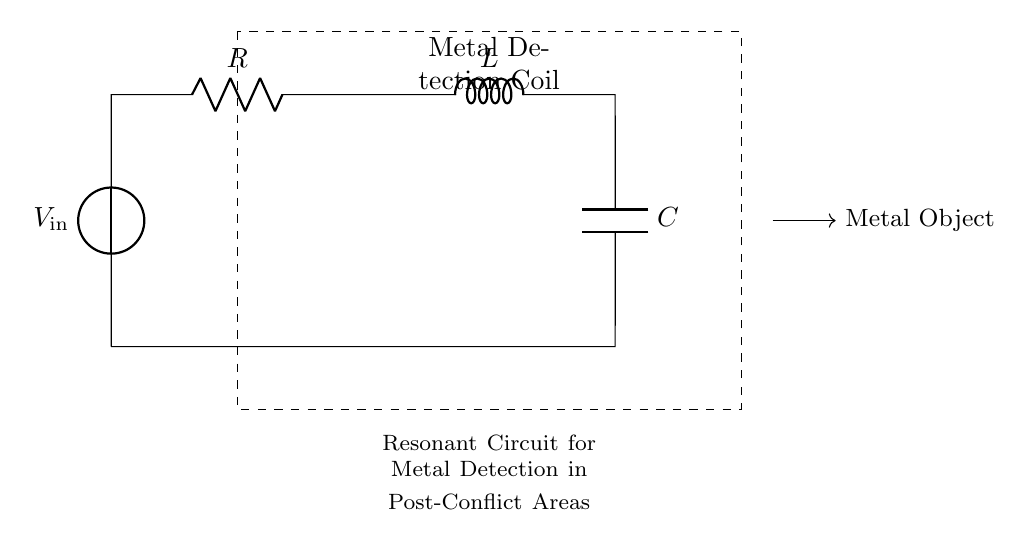What components are in the circuit? The circuit contains a voltage source, a resistor, an inductor, and a capacitor. These components are arranged in a loop, demonstrating a basic resonant circuit.
Answer: Voltage source, resistor, inductor, capacitor What does the dashed rectangle represent? The dashed rectangle encloses the metal detection coil, indicating the specific area of the circuit where metal detection occurs. It labels this section for clarity.
Answer: Metal Detection Coil How does the circuit detect metal? The circuit detects metal by utilizing the resonant frequency, which changes in the presence of a metal object due to changes in the inductive and capacitive components. When metal is present, it affects the circuit's inductance, altering the resonant frequency.
Answer: Changes in resonant frequency What is the primary function of the inductor in this circuit? The inductor's primary function is to store energy in its magnetic field and influence the circuit's resonant frequency. By affecting the impedance, it plays a crucial role in tuning the circuit for metal detection.
Answer: Store energy, influence resonant frequency What type of circuit is depicted here? The circuit is a resonant circuit specifically designed for metal detection. It exhibits characteristics of a series RLC circuit, where the components work together to achieve resonance at specific frequencies for detecting metal.
Answer: Resonant circuit What happens to the circuit's resonant frequency when metal is detected? When metal is detected, the resonant frequency decreases due to an increase in the effective inductance, caused by the interaction of the metal with the magnetic field produced by the inductor. This shift indicates the presence of metal.
Answer: Decreases 